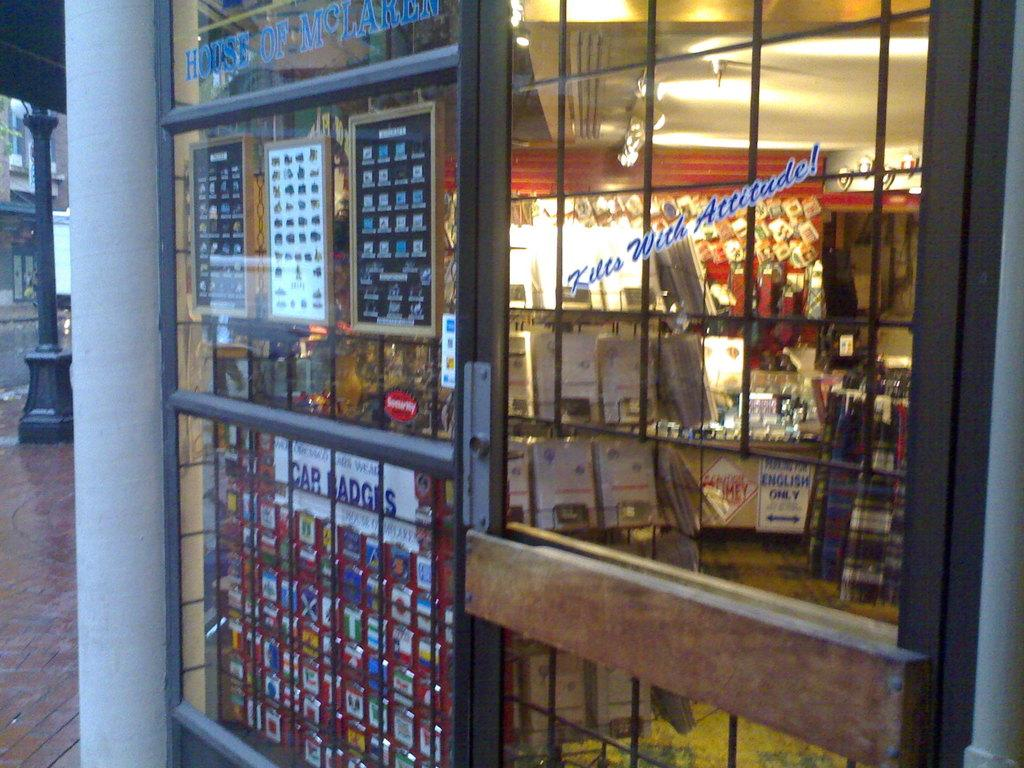Provide a one-sentence caption for the provided image. A window to the inside the plaid fabric shop has a sign that reads "Kilts with Attitude!". 